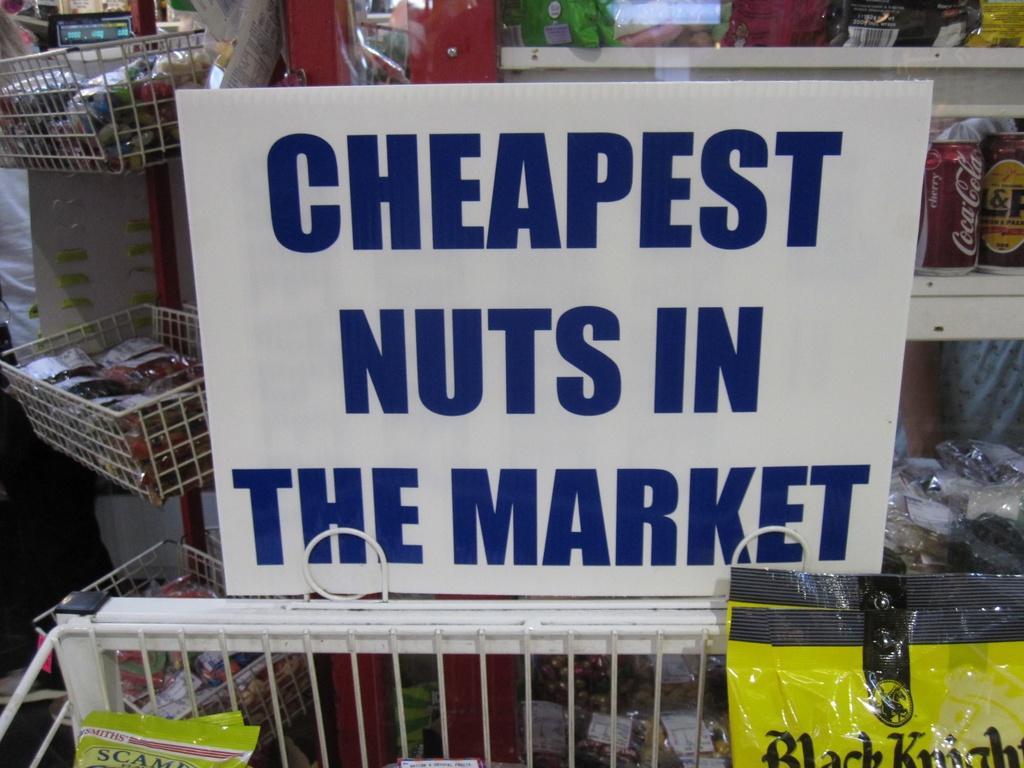In one or two sentences, can you explain what this image depicts? In this picture I can see e a board with some text and I can see few items in the shelves and few items in the baskets, looks like a store. 